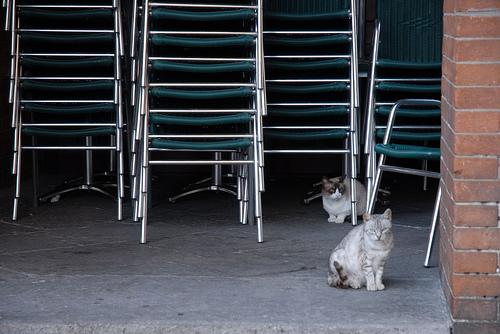If a few more of these animals appear here what would they be called? cats 